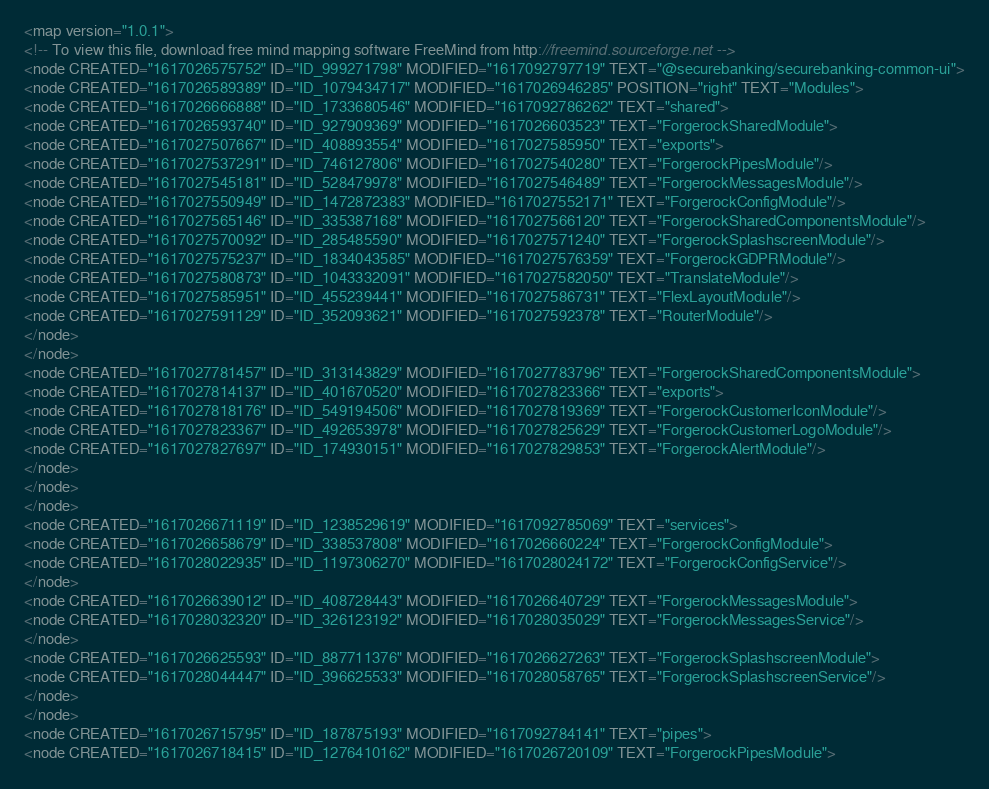Convert code to text. <code><loc_0><loc_0><loc_500><loc_500><_ObjectiveC_><map version="1.0.1">
<!-- To view this file, download free mind mapping software FreeMind from http://freemind.sourceforge.net -->
<node CREATED="1617026575752" ID="ID_999271798" MODIFIED="1617092797719" TEXT="@securebanking/securebanking-common-ui">
<node CREATED="1617026589389" ID="ID_1079434717" MODIFIED="1617026946285" POSITION="right" TEXT="Modules">
<node CREATED="1617026666888" ID="ID_1733680546" MODIFIED="1617092786262" TEXT="shared">
<node CREATED="1617026593740" ID="ID_927909369" MODIFIED="1617026603523" TEXT="ForgerockSharedModule">
<node CREATED="1617027507667" ID="ID_408893554" MODIFIED="1617027585950" TEXT="exports">
<node CREATED="1617027537291" ID="ID_746127806" MODIFIED="1617027540280" TEXT="ForgerockPipesModule"/>
<node CREATED="1617027545181" ID="ID_528479978" MODIFIED="1617027546489" TEXT="ForgerockMessagesModule"/>
<node CREATED="1617027550949" ID="ID_1472872383" MODIFIED="1617027552171" TEXT="ForgerockConfigModule"/>
<node CREATED="1617027565146" ID="ID_335387168" MODIFIED="1617027566120" TEXT="ForgerockSharedComponentsModule"/>
<node CREATED="1617027570092" ID="ID_285485590" MODIFIED="1617027571240" TEXT="ForgerockSplashscreenModule"/>
<node CREATED="1617027575237" ID="ID_1834043585" MODIFIED="1617027576359" TEXT="ForgerockGDPRModule"/>
<node CREATED="1617027580873" ID="ID_1043332091" MODIFIED="1617027582050" TEXT="TranslateModule"/>
<node CREATED="1617027585951" ID="ID_455239441" MODIFIED="1617027586731" TEXT="FlexLayoutModule"/>
<node CREATED="1617027591129" ID="ID_352093621" MODIFIED="1617027592378" TEXT="RouterModule"/>
</node>
</node>
<node CREATED="1617027781457" ID="ID_313143829" MODIFIED="1617027783796" TEXT="ForgerockSharedComponentsModule">
<node CREATED="1617027814137" ID="ID_401670520" MODIFIED="1617027823366" TEXT="exports">
<node CREATED="1617027818176" ID="ID_549194506" MODIFIED="1617027819369" TEXT="ForgerockCustomerIconModule"/>
<node CREATED="1617027823367" ID="ID_492653978" MODIFIED="1617027825629" TEXT="ForgerockCustomerLogoModule"/>
<node CREATED="1617027827697" ID="ID_174930151" MODIFIED="1617027829853" TEXT="ForgerockAlertModule"/>
</node>
</node>
</node>
<node CREATED="1617026671119" ID="ID_1238529619" MODIFIED="1617092785069" TEXT="services">
<node CREATED="1617026658679" ID="ID_338537808" MODIFIED="1617026660224" TEXT="ForgerockConfigModule">
<node CREATED="1617028022935" ID="ID_1197306270" MODIFIED="1617028024172" TEXT="ForgerockConfigService"/>
</node>
<node CREATED="1617026639012" ID="ID_408728443" MODIFIED="1617026640729" TEXT="ForgerockMessagesModule">
<node CREATED="1617028032320" ID="ID_326123192" MODIFIED="1617028035029" TEXT="ForgerockMessagesService"/>
</node>
<node CREATED="1617026625593" ID="ID_887711376" MODIFIED="1617026627263" TEXT="ForgerockSplashscreenModule">
<node CREATED="1617028044447" ID="ID_396625533" MODIFIED="1617028058765" TEXT="ForgerockSplashscreenService"/>
</node>
</node>
<node CREATED="1617026715795" ID="ID_187875193" MODIFIED="1617092784141" TEXT="pipes">
<node CREATED="1617026718415" ID="ID_1276410162" MODIFIED="1617026720109" TEXT="ForgerockPipesModule"></code> 